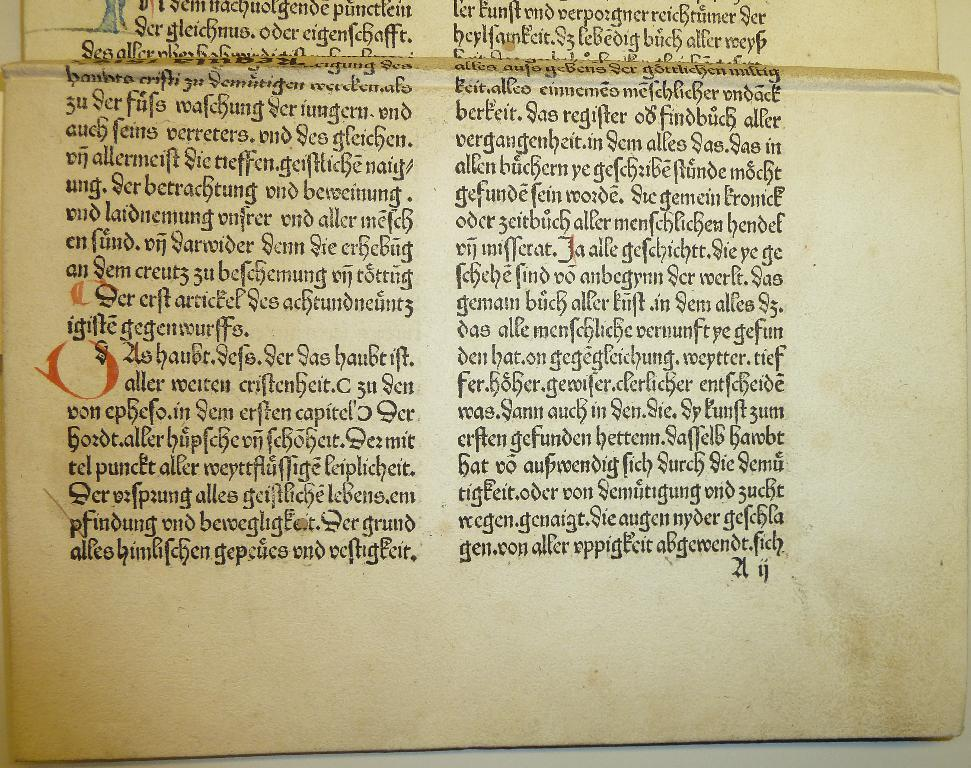Provide a one-sentence caption for the provided image. A page of a very old books with German writing in a very elaborate font. 